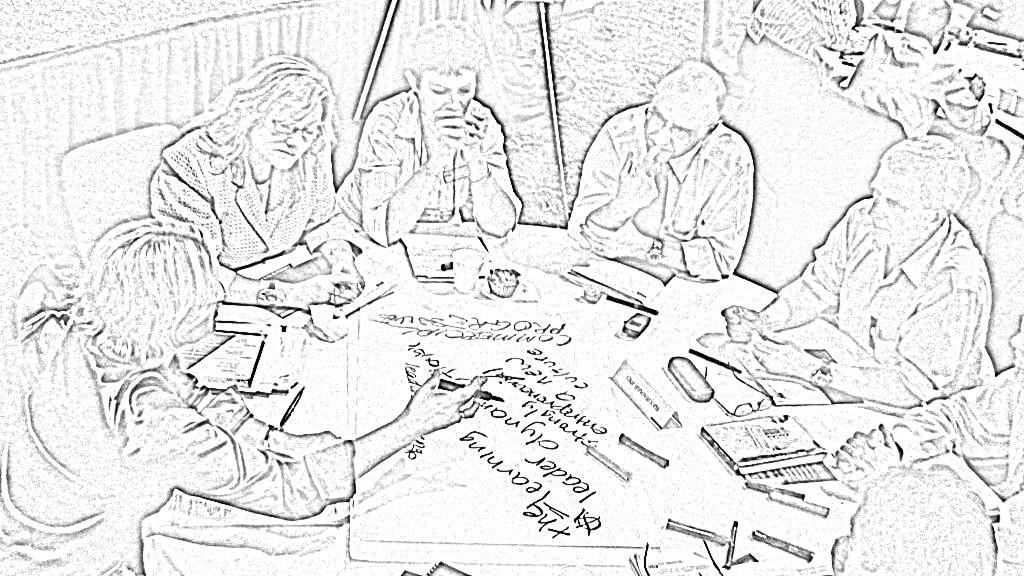What type of drawing is depicted in the image? The image is a sketch. What are the people in the image doing? The people are sitting on chairs. What piece of furniture is present in the image? There is a table in the image. What can be found on the table? There are objects on the table. What is the title of the poem written on the table in the image? There is no poem or title present on the table in the image; it only contains objects. 